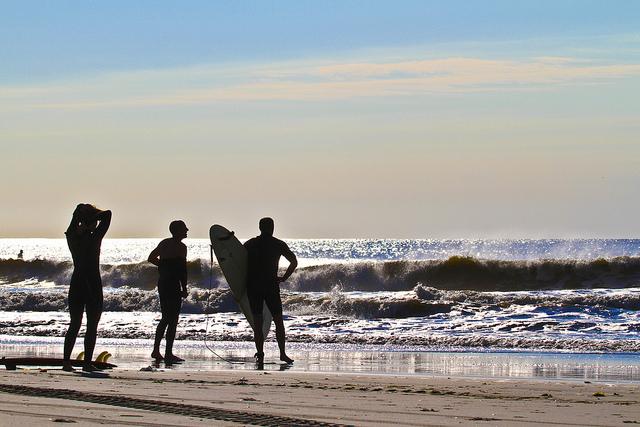What activity are they going to do?
Quick response, please. Surfing. What time of day was this picture taken?
Write a very short answer. Sunset. During the day?
Short answer required. Yes. 